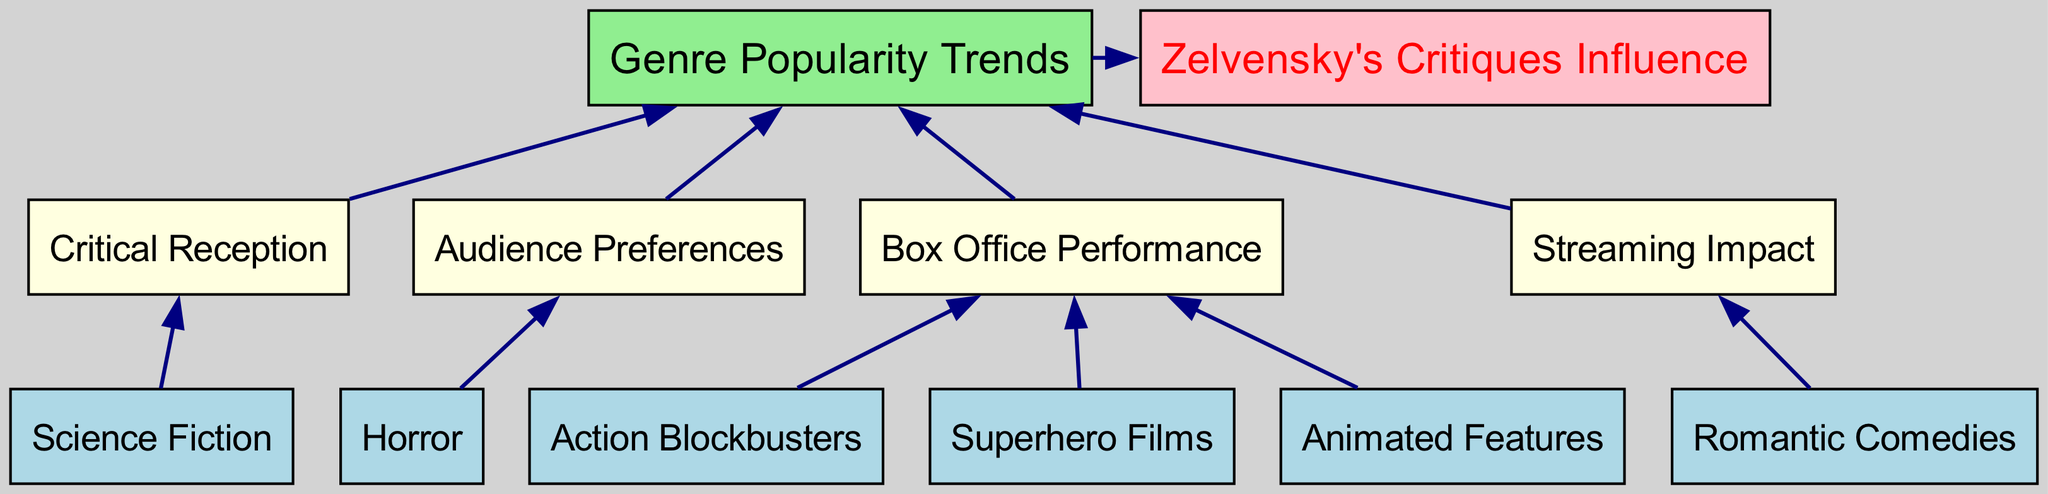What are the bottom-level genres shown in the diagram? The bottom-level genres are explicitly listed within the diagram, showcasing genres that have been analyzed for popularity trends. These genres are: Action Blockbusters, Superhero Films, Science Fiction, Horror, Romantic Comedies, and Animated Features.
Answer: Action Blockbusters, Superhero Films, Science Fiction, Horror, Romantic Comedies, Animated Features How many mid-level categories are there? The mid-level categories are denoted in the diagram and represent the factors influencing genre popularity. There are four mid-level categories: Box Office Performance, Critical Reception, Audience Preferences, and Streaming Impact.
Answer: 4 Which genre connects to Audience Preferences? The diagram illustrates the connection between Horror and Audience Preferences, indicating that this genre is assessed in relation to how audiences respond to it.
Answer: Horror How does Box Office Performance influence Genre Popularity Trends? The flow chart shows a direct connection from Box Office Performance to Genre Popularity Trends, indicating that the financial success of films contributes to the overall popularity trends of various genres.
Answer: Direct connection What is the final outcome indicated by the top-level category? The top-level category depicts the overall outcome that emerges from the analysis of lower-level categories, culminating in insights regarding Genre Popularity Trends and the Influence of Zelvensky's Critiques.
Answer: Genre Popularity Trends, Zelvensky's Critiques Influence Which genre is linked to Streaming Impact? The diagram specifies that Romantic Comedies connect to Streaming Impact, highlighting the significance of streaming services in the popularity of this genre.
Answer: Romantic Comedies How many edges connect the bottom-level genres to the mid-level categories? By examining the connections in the diagram, it can be determined that there are a total of six edges linking the bottom-level genres to the four mid-level categories.
Answer: 6 Describe the relationship between Critical Reception and Genre Popularity Trends. The diagram establishes a flow from Critical Reception to Genre Popularity Trends, suggesting that the critical reception of films, which is influenced by reviews and critiques, plays a significant role in shaping the popularity of different genres over time.
Answer: Critical Reception influences Genre Popularity Trends Which color represents the mid-level category in the diagram? Upon inspecting the diagram, it is clear that the mid-level categories are depicted in light yellow, distinguishing them from the other levels in the chart.
Answer: Light yellow 